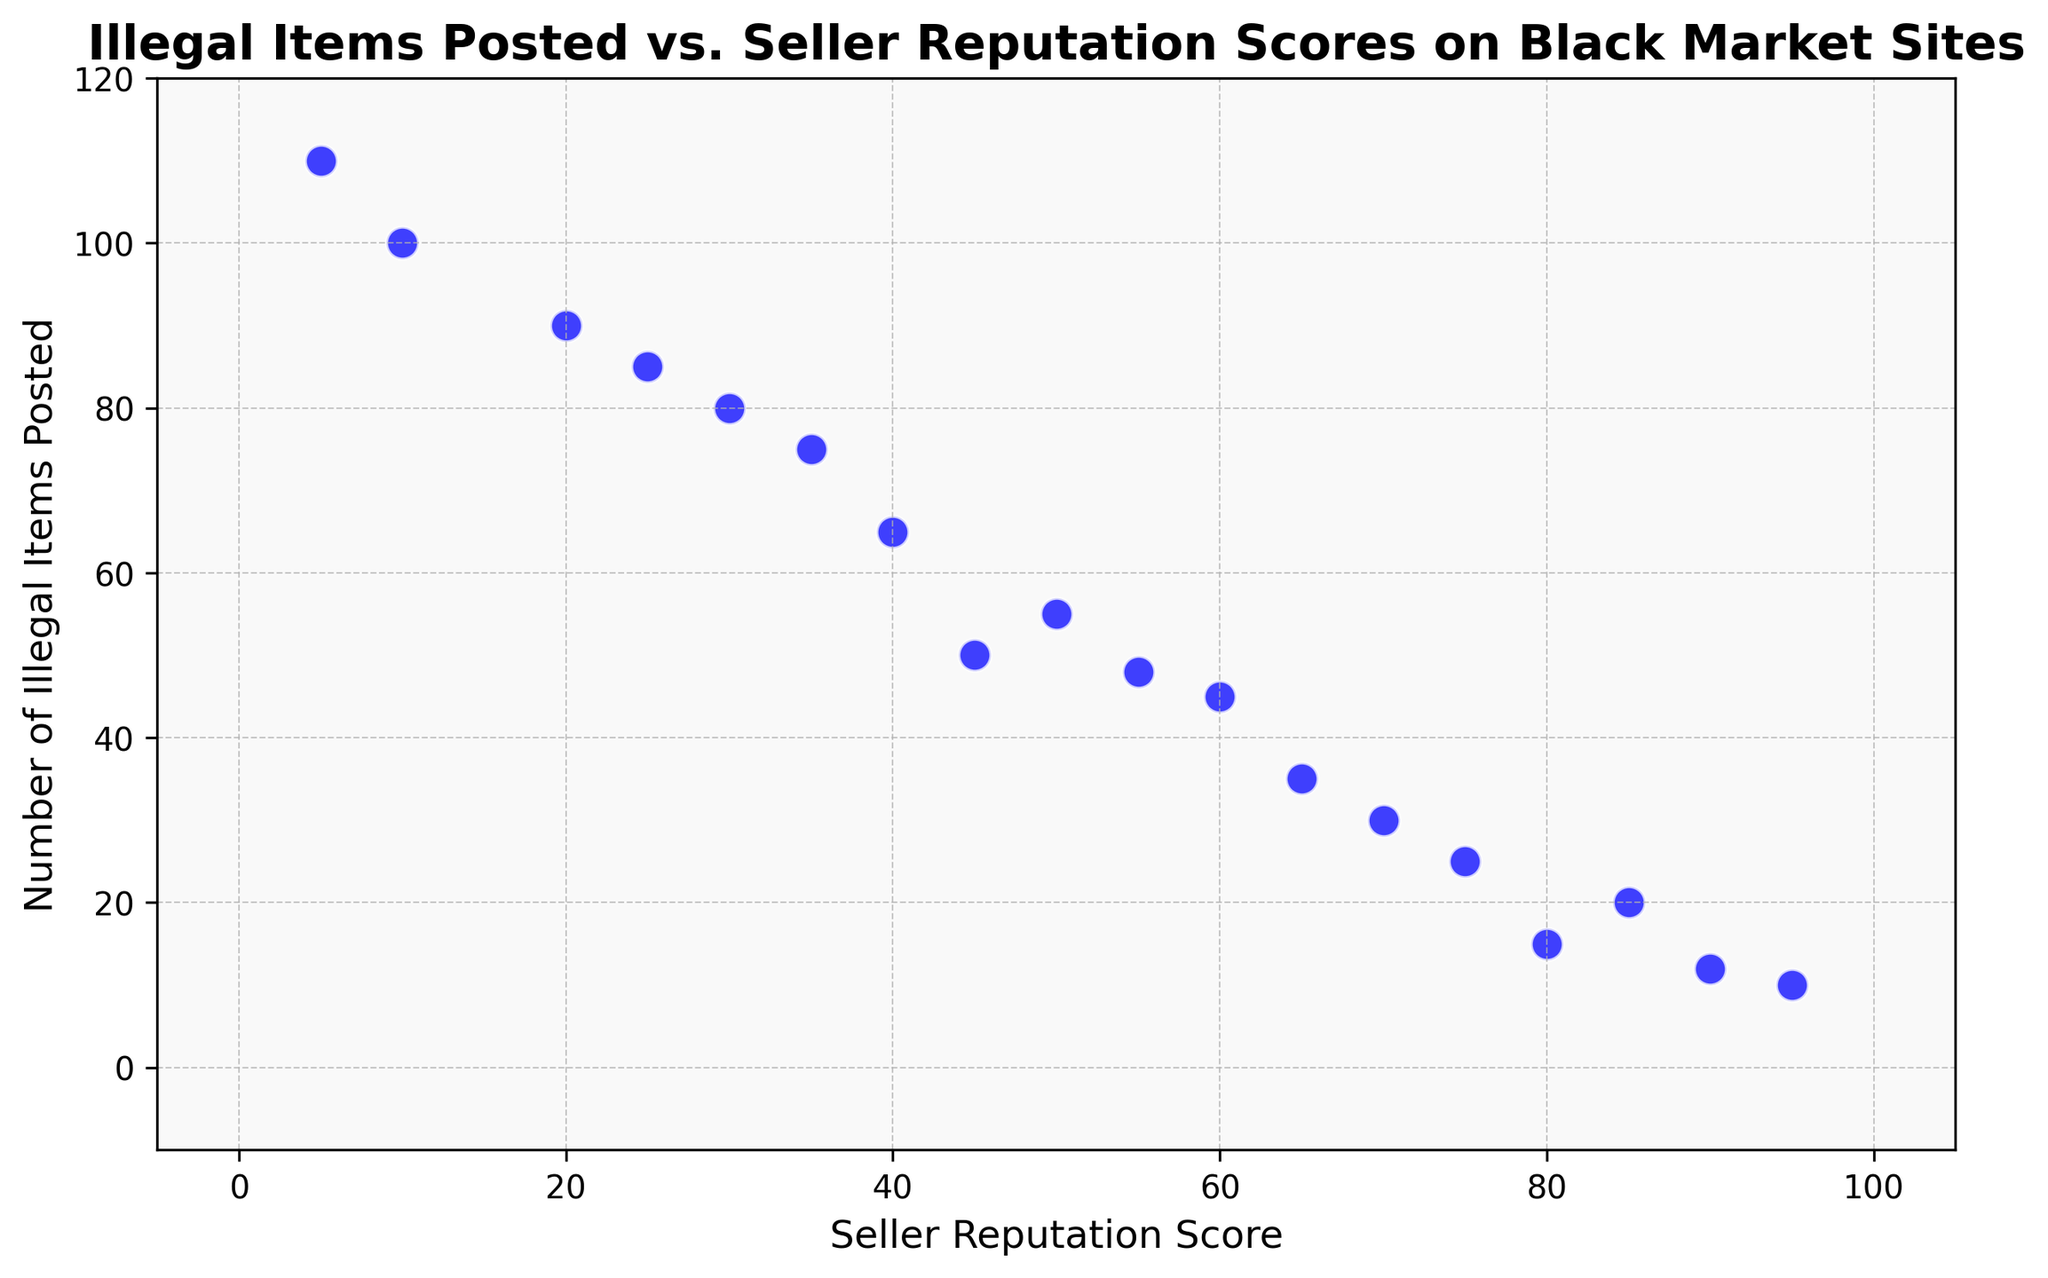What is the general trend observed between the Seller Reputation Score and the Number of Illegal Items Posted? The general trend shows that as the Seller Reputation Score decreases, the Number of Illegal Items Posted increases. This is evident as the points on the scatter plot form a downward trend from top left to bottom right.
Answer: As the Seller Reputation Score decreases, the Number of Illegal Items Posted increases Which seller has the highest Seller Reputation Score, and how many illegal items did they post? The seller with the highest Seller Reputation Score is at the far right of the scatter plot. This score is 95, and they posted 10 illegal items.
Answer: Seller with a score of 95 posted 10 illegal items Compare the number of illegal items posted by sellers with reputation scores 80 and 50. For a reputation score of 80, the seller posted 15 illegal items. For a reputation score of 50, the seller posted 55 illegal items. By comparing these, the seller with a reputation score of 50 posted 40 more illegal items than the seller with a reputation score of 80.
Answer: The seller with a score of 50 posted 40 more items than the one with a score of 80 What is the average number of illegal items posted by the sellers with reputation scores above 70? The sellers with reputation scores above 70 are 95 (10 items), 80 (15 items), 85 (20 items), 90 (12 items), and 75 (25 items). Sum of items is 10 + 15 + 20 + 12 + 25 = 82. There are 5 sellers, so the average is 82 / 5.
Answer: 16.4 Which seller posted the most illegal items and what was their reputation score? The seller who posted the most illegal items is represented by the highest point on the y-axis. This point indicates 110 illegal items and a Seller Reputation Score of 5.
Answer: Seller posted 110 items, and their reputation score is 5 How does the number of illegal items posted compare for sellers with reputation scores 25 and 35? The seller with a reputation score of 25 posted 85 illegal items, while the seller with a score of 35 posted 75 illegal items. By comparing these, the seller with a score of 25 posted 10 more illegal items than the one with a score of 35.
Answer: Seller with a score of 25 posted 10 more items than the one with a score of 35 If you group sellers into those with reputation scores above 50 and below 50, which group posted more illegal items on average? Sellers with scores above 50 posted items: 95 (10), 80 (15), 70 (30), 85 (20), 90 (12), 60 (45), 75 (25), 55 (48). Sum of items: 10 + 15 + 30 + 20 + 12 + 45 + 25 + 48 = 205. There are 8 sellers, so the average is 205 / 8 = 25.625. Sellers with scores below 50 posted items: 50 (55), 40 (65), 30 (80), 45 (50), 35 (75), 20 (90), 25 (85), 10 (100), 5 (110). Sum of items: 55 + 65 + 80 + 50 + 75 + 90 + 85 + 100 + 110 = 710. There are 9 sellers, so the average is 710 / 9 = 78.89.
Answer: Sellers with scores below 50 posted more on average (78.89) What can we infer about sellers with low reputation scores based on the scatter plot? Sellers with low reputation scores generally have higher numbers of illegal items posted. This inference is based on observing data points that show lower scores on the x-axis corresponding to higher values on the y-axis.
Answer: Low reputation scores are associated with higher illegal items posted Which specific data points, if any, deviate significantly from the general trend? The general trend shows a decrease in reputation score corresponding with an increase in illegal items posted. To find deviations, one would look for points that don't follow this trend. Most points adhere to the trend, and no significant outliers are immediately apparent from the scatter plot.
Answer: No significant outliers from the trend How many sellers posted fewer than 20 illegal items? To determine this, we look at data points with y-values (illegal items posted) less than 20. The sellers have reputation scores of 95 (10), 80 (15), 90 (12). Thus, three sellers posted fewer than 20 illegal items.
Answer: 3 sellers 